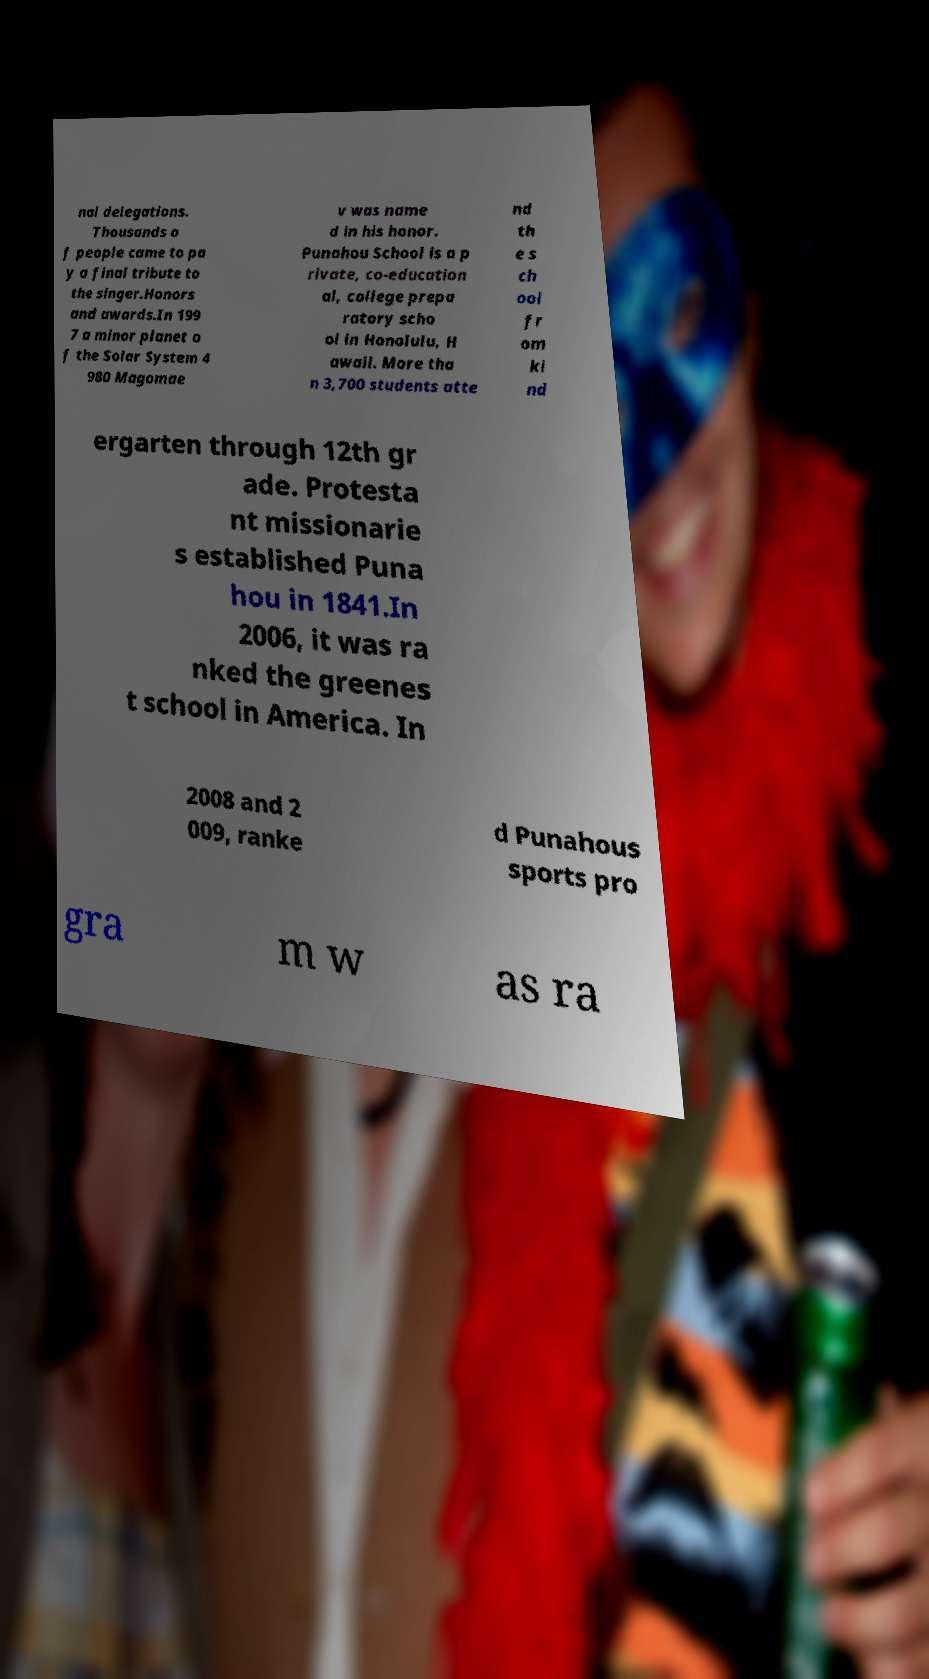Could you assist in decoding the text presented in this image and type it out clearly? nal delegations. Thousands o f people came to pa y a final tribute to the singer.Honors and awards.In 199 7 a minor planet o f the Solar System 4 980 Magomae v was name d in his honor. Punahou School is a p rivate, co-education al, college prepa ratory scho ol in Honolulu, H awaii. More tha n 3,700 students atte nd th e s ch ool fr om ki nd ergarten through 12th gr ade. Protesta nt missionarie s established Puna hou in 1841.In 2006, it was ra nked the greenes t school in America. In 2008 and 2 009, ranke d Punahous sports pro gra m w as ra 